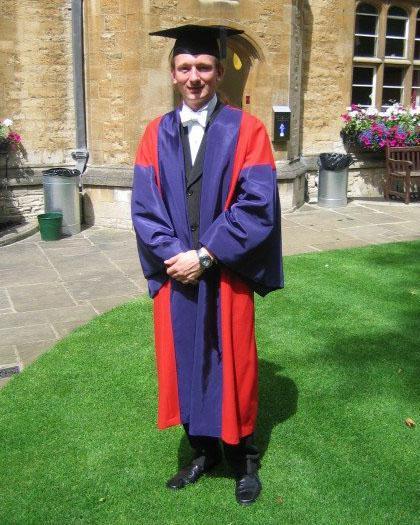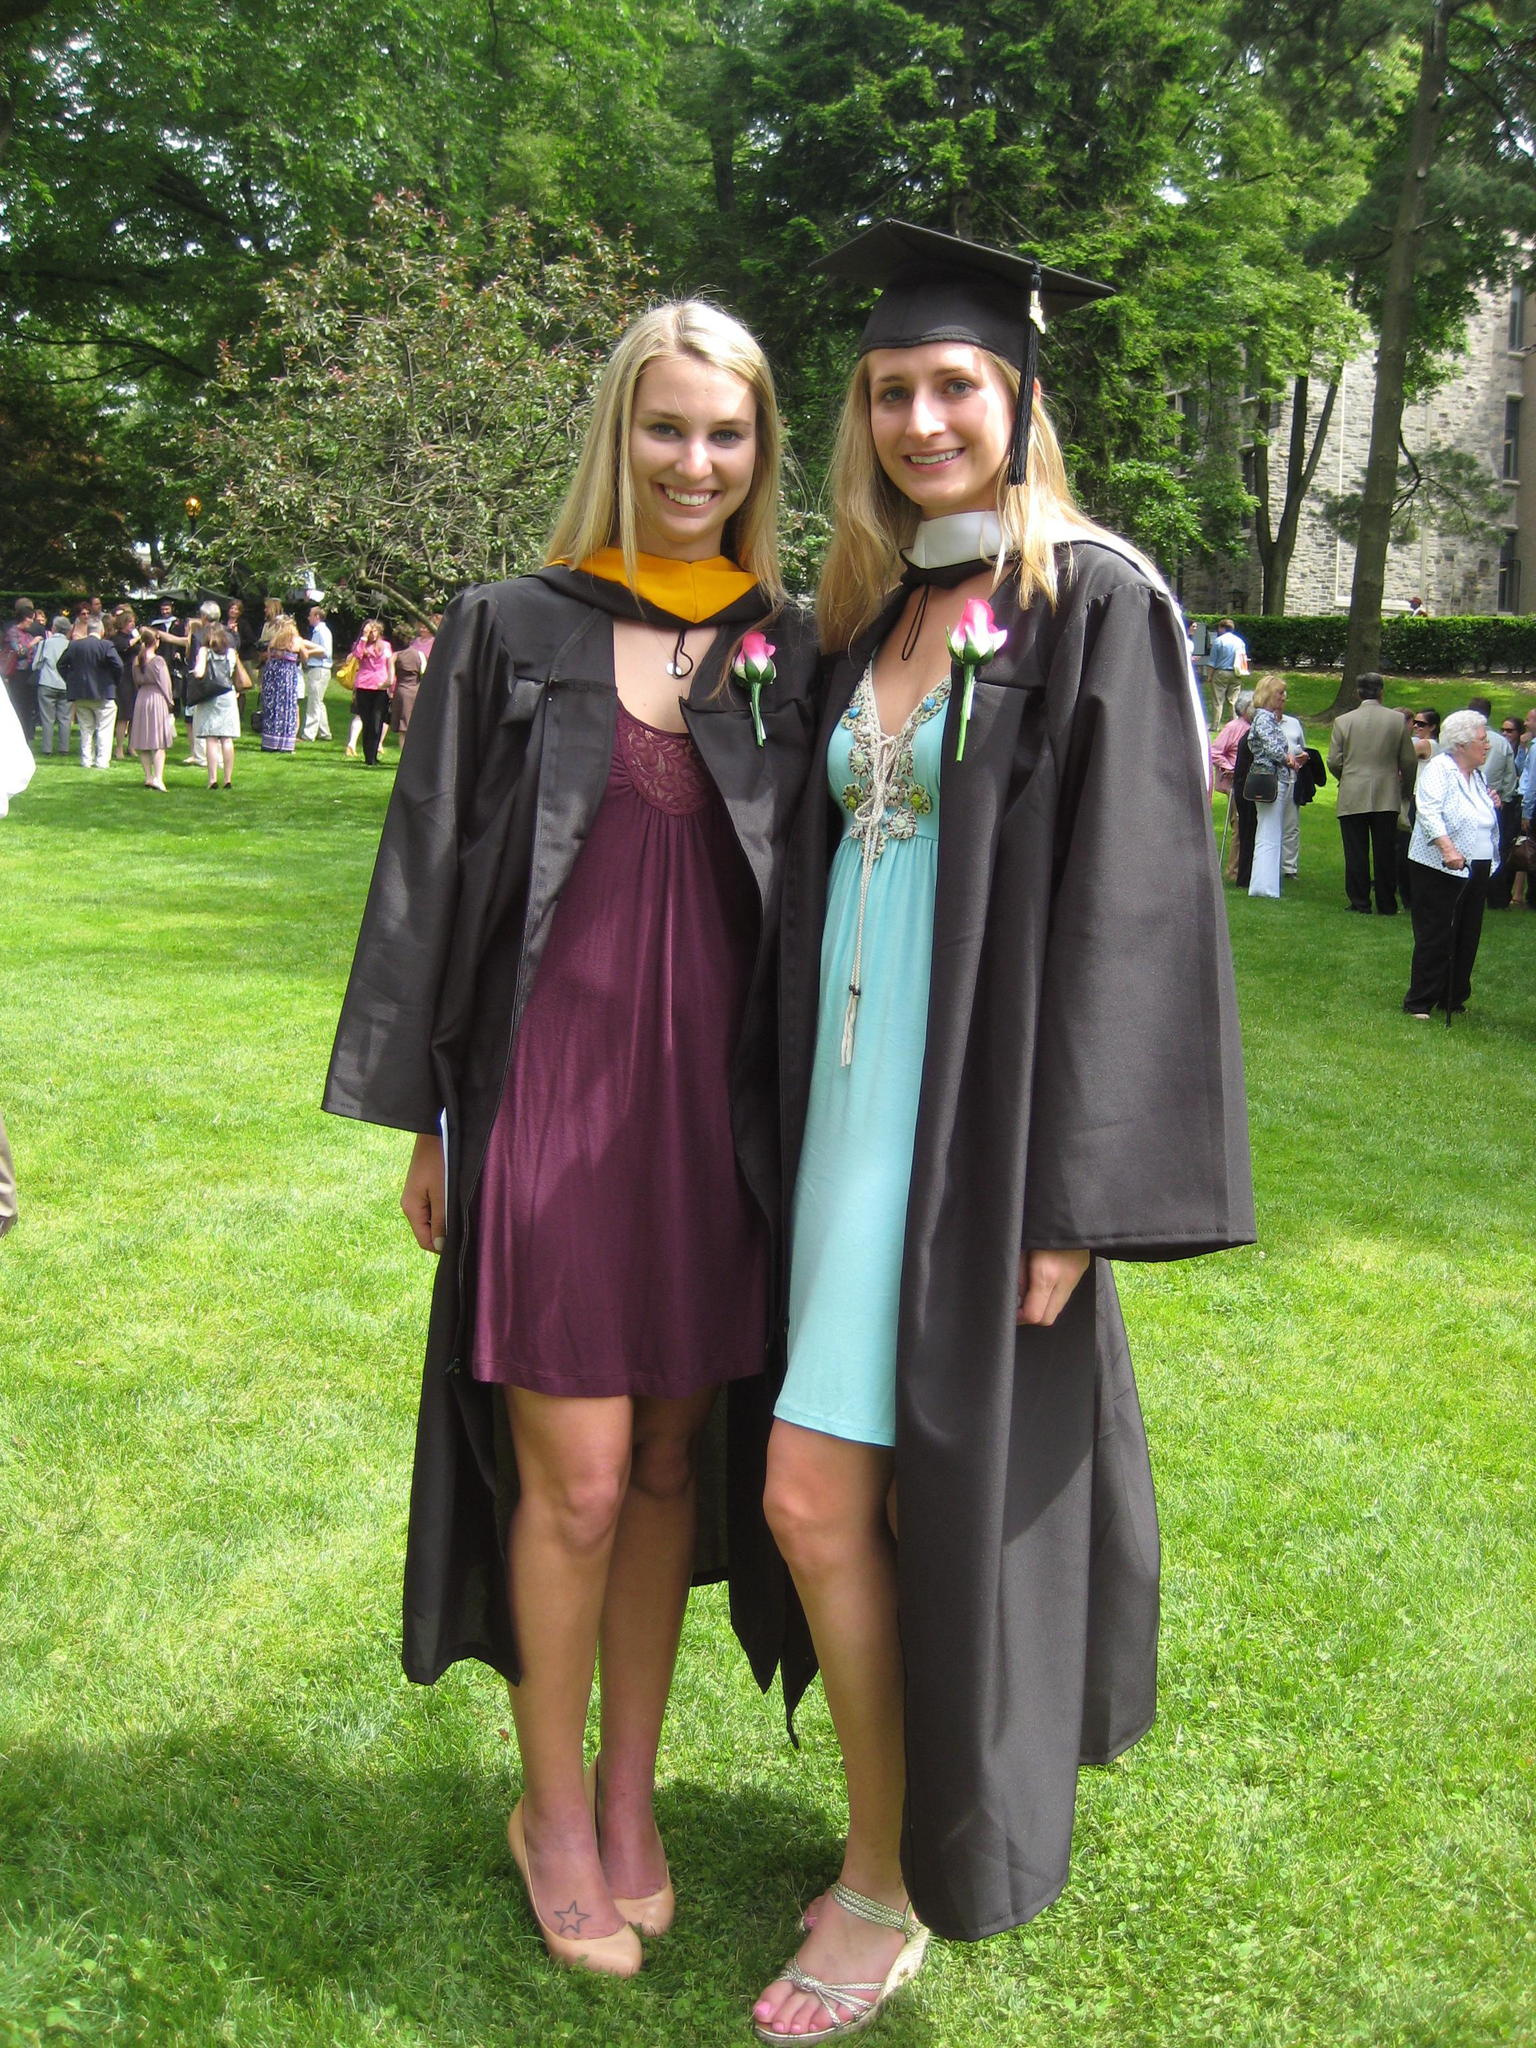The first image is the image on the left, the second image is the image on the right. Assess this claim about the two images: "There are total of three graduates.". Correct or not? Answer yes or no. Yes. 